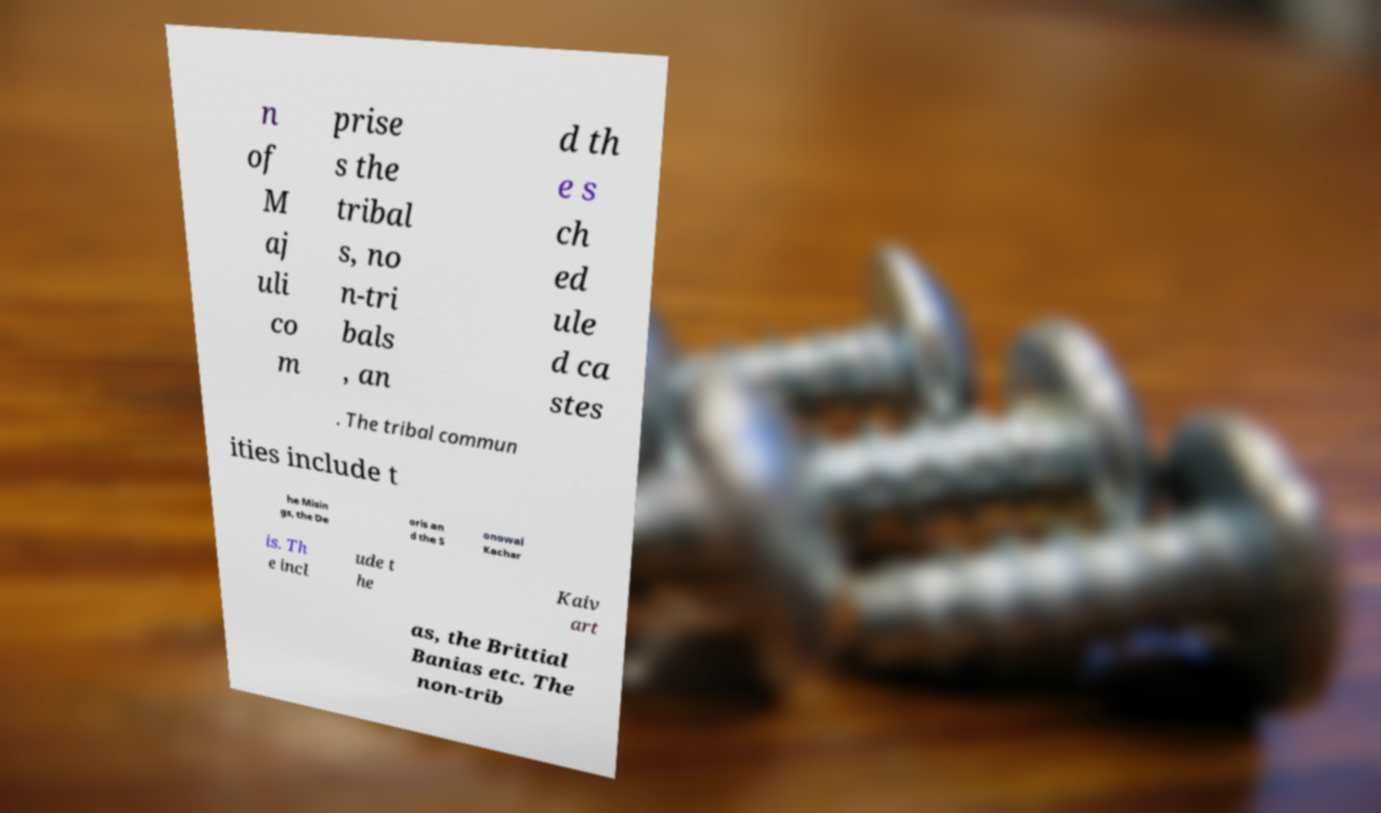Could you assist in decoding the text presented in this image and type it out clearly? n of M aj uli co m prise s the tribal s, no n-tri bals , an d th e s ch ed ule d ca stes . The tribal commun ities include t he Misin gs, the De oris an d the S onowal Kachar is. Th e incl ude t he Kaiv art as, the Brittial Banias etc. The non-trib 